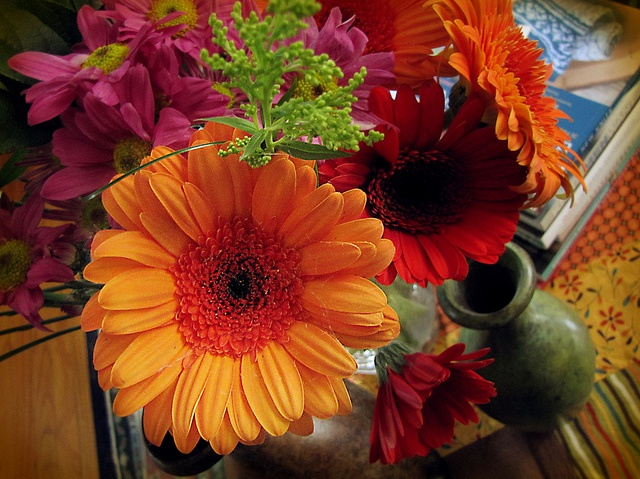Describe the objects in this image and their specific colors. I can see vase in black, darkgreen, and olive tones, book in black, darkgray, gray, tan, and teal tones, vase in black, maroon, and gray tones, and vase in black, gray, and olive tones in this image. 